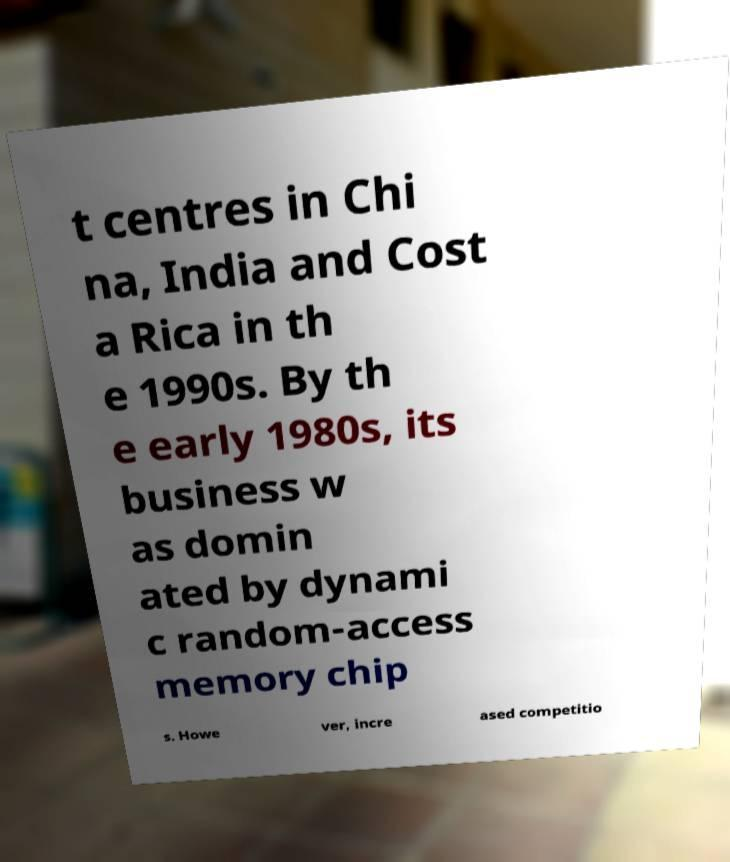I need the written content from this picture converted into text. Can you do that? t centres in Chi na, India and Cost a Rica in th e 1990s. By th e early 1980s, its business w as domin ated by dynami c random-access memory chip s. Howe ver, incre ased competitio 